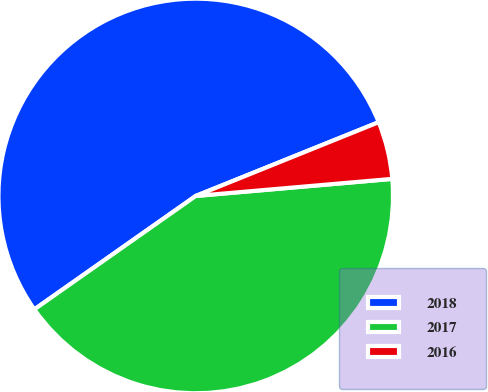Convert chart. <chart><loc_0><loc_0><loc_500><loc_500><pie_chart><fcel>2018<fcel>2017<fcel>2016<nl><fcel>53.65%<fcel>41.63%<fcel>4.72%<nl></chart> 